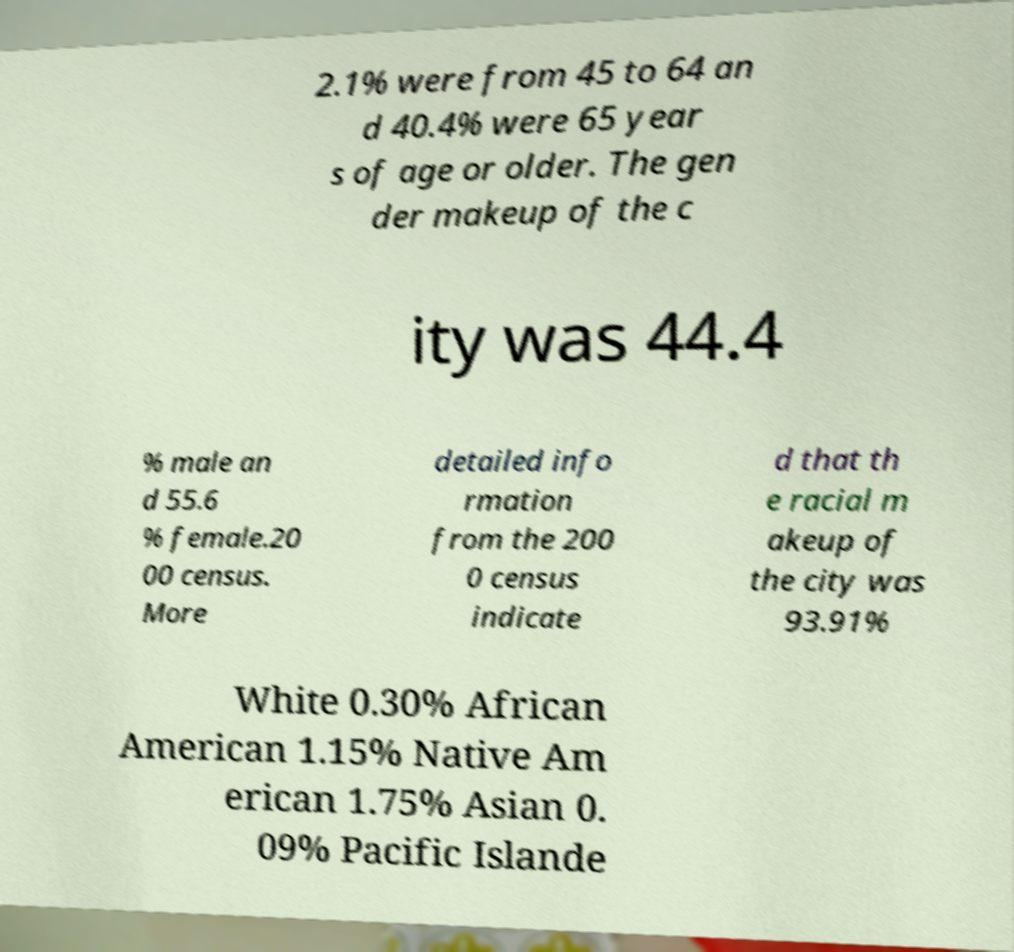There's text embedded in this image that I need extracted. Can you transcribe it verbatim? 2.1% were from 45 to 64 an d 40.4% were 65 year s of age or older. The gen der makeup of the c ity was 44.4 % male an d 55.6 % female.20 00 census. More detailed info rmation from the 200 0 census indicate d that th e racial m akeup of the city was 93.91% White 0.30% African American 1.15% Native Am erican 1.75% Asian 0. 09% Pacific Islande 